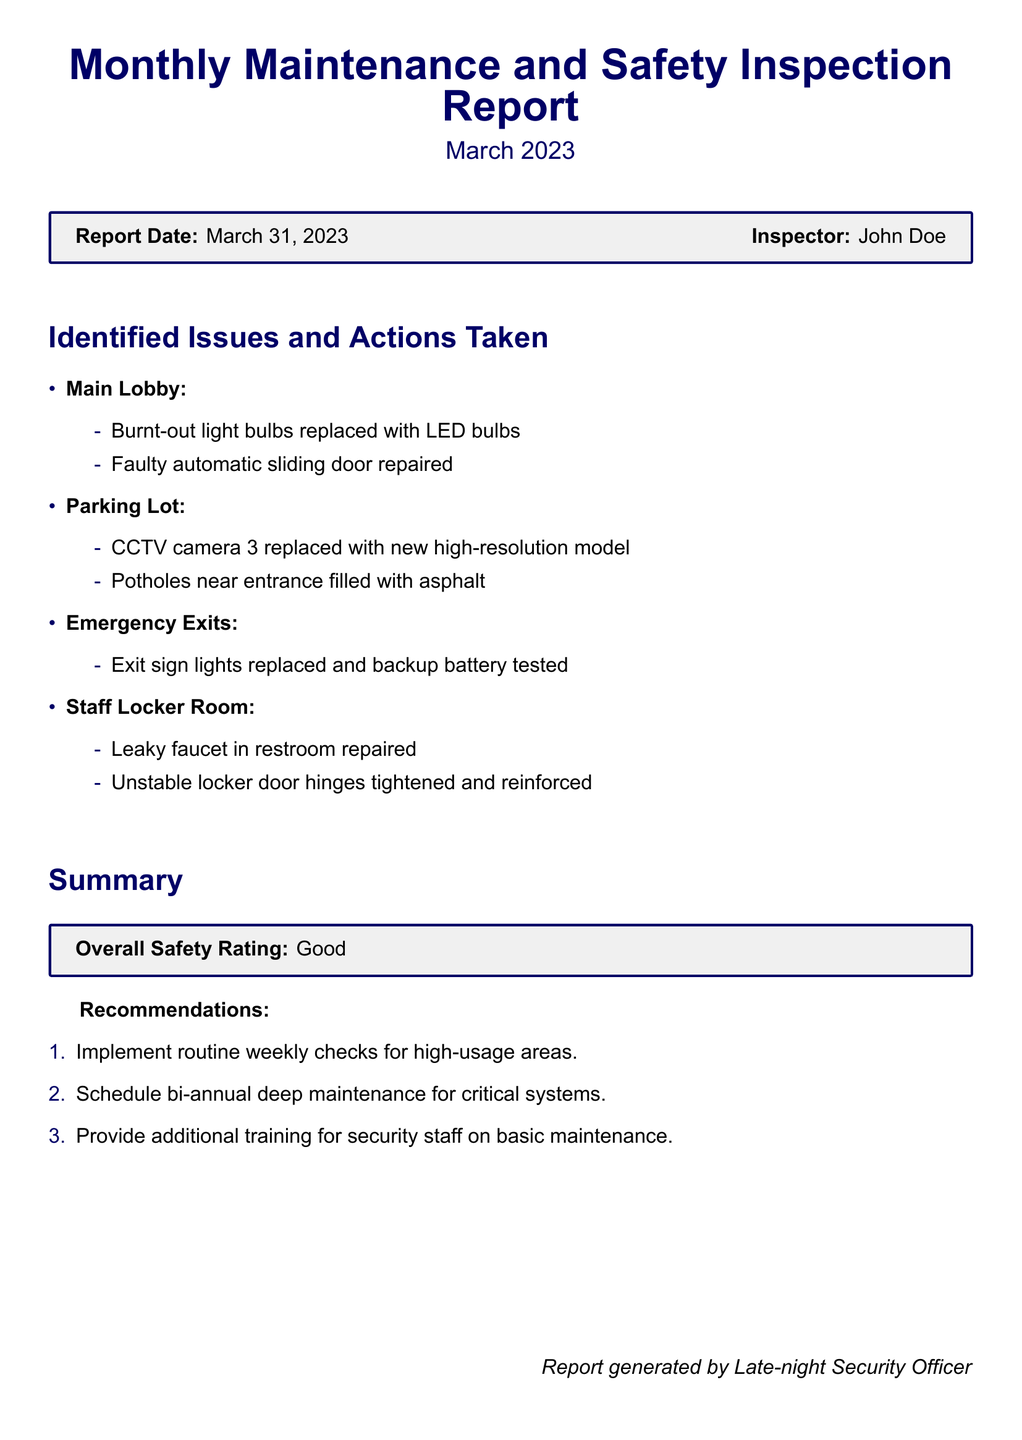What is the report date? The report date is stated at the beginning of the document under the report details.
Answer: March 31, 2023 Who was the inspector for this report? The name of the inspector is provided alongside the report date.
Answer: John Doe What was replaced in the Main Lobby? The issues and actions taken in each area include specific items identified and actions taken, for the Main Lobby specifically.
Answer: LED bulbs What was done in the Parking Lot? The actions taken in the Parking Lot covers multiple issues as noted in the document.
Answer: CCTV camera 3 replaced How many recommendations are listed? The document includes a section outlining specific recommendations after presenting identified issues and actions taken.
Answer: 3 What is the overall safety rating? The overall safety rating is summarized at the end of the report in a highlighted box.
Answer: Good What maintenance frequency is recommended for critical systems? Recommendations suggest a specific maintenance schedule for ensuring safety in the facility.
Answer: Bi-annual Which room had a leaky faucet repaired? The document specifically identifies which room had issues addressed and actions taken within it.
Answer: Staff Locker Room What was done to the emergency exit signs? The action taken regarding emergency exit signs is noted in the identified issues section of the document.
Answer: Exit sign lights replaced 